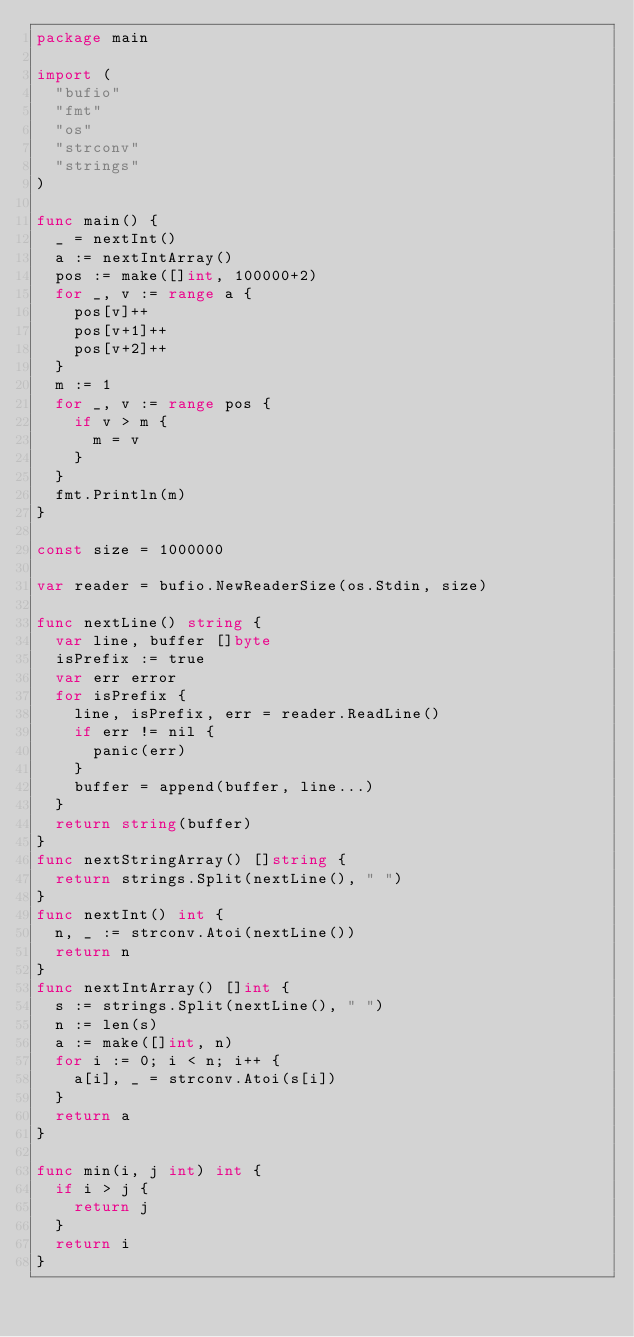<code> <loc_0><loc_0><loc_500><loc_500><_Go_>package main

import (
	"bufio"
	"fmt"
	"os"
	"strconv"
	"strings"
)

func main() {
	_ = nextInt()
	a := nextIntArray()
	pos := make([]int, 100000+2)
	for _, v := range a {
		pos[v]++
		pos[v+1]++
		pos[v+2]++
	}
	m := 1
	for _, v := range pos {
		if v > m {
			m = v
		}
	}
	fmt.Println(m)
}

const size = 1000000

var reader = bufio.NewReaderSize(os.Stdin, size)

func nextLine() string {
	var line, buffer []byte
	isPrefix := true
	var err error
	for isPrefix {
		line, isPrefix, err = reader.ReadLine()
		if err != nil {
			panic(err)
		}
		buffer = append(buffer, line...)
	}
	return string(buffer)
}
func nextStringArray() []string {
	return strings.Split(nextLine(), " ")
}
func nextInt() int {
	n, _ := strconv.Atoi(nextLine())
	return n
}
func nextIntArray() []int {
	s := strings.Split(nextLine(), " ")
	n := len(s)
	a := make([]int, n)
	for i := 0; i < n; i++ {
		a[i], _ = strconv.Atoi(s[i])
	}
	return a
}

func min(i, j int) int {
	if i > j {
		return j
	}
	return i
}
</code> 